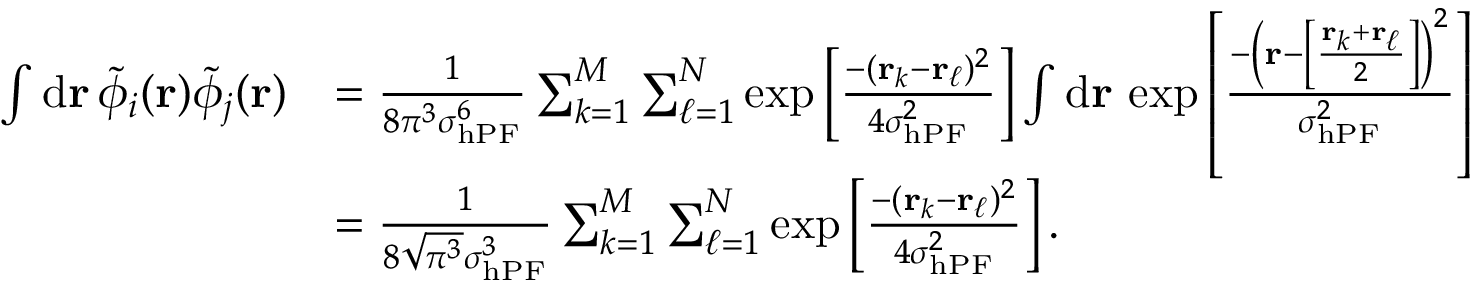Convert formula to latex. <formula><loc_0><loc_0><loc_500><loc_500>\begin{array} { r l } { \int d r \, \tilde { \phi } _ { i } ( r ) \tilde { \phi } _ { j } ( r ) } & { = \frac { 1 } { 8 \pi ^ { 3 } \sigma _ { h P F } ^ { 6 } } \sum _ { k = 1 } ^ { M } \sum _ { \ell = 1 } ^ { N } \exp \left [ \frac { - ( r _ { k } - r _ { \ell } ) ^ { 2 } } { 4 \sigma _ { h P F } ^ { 2 } } \right ] \int d r \, \exp \left [ \frac { - \left ( r - \left [ \frac { r _ { k } + r _ { \ell } } { 2 } \right ] \right ) ^ { 2 } } { \sigma _ { h P F } ^ { 2 } } \right ] } \\ & { = \frac { 1 } { 8 \sqrt { \pi ^ { 3 } } \sigma _ { h P F } ^ { 3 } } \sum _ { k = 1 } ^ { M } \sum _ { \ell = 1 } ^ { N } \exp \left [ \frac { - ( r _ { k } - r _ { \ell } ) ^ { 2 } } { 4 \sigma _ { h P F } ^ { 2 } } \right ] . } \end{array}</formula> 